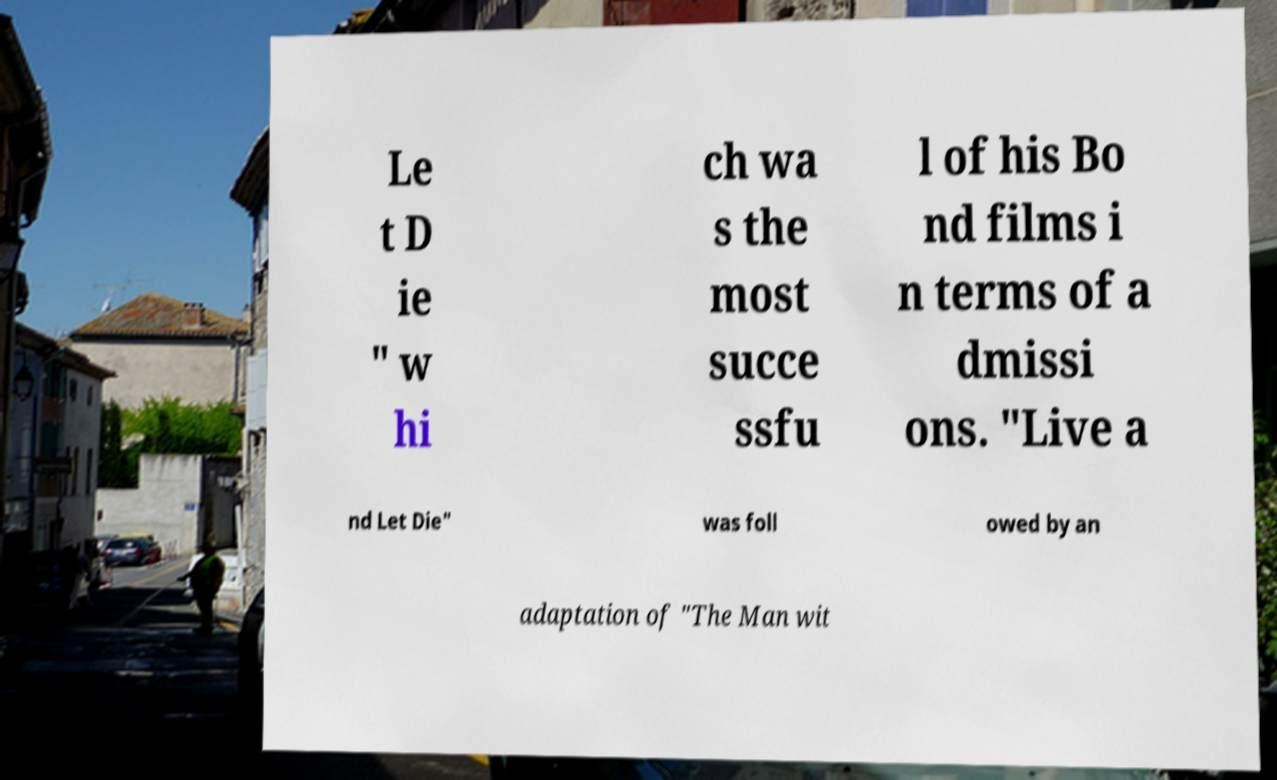Could you assist in decoding the text presented in this image and type it out clearly? Le t D ie " w hi ch wa s the most succe ssfu l of his Bo nd films i n terms of a dmissi ons. "Live a nd Let Die" was foll owed by an adaptation of "The Man wit 